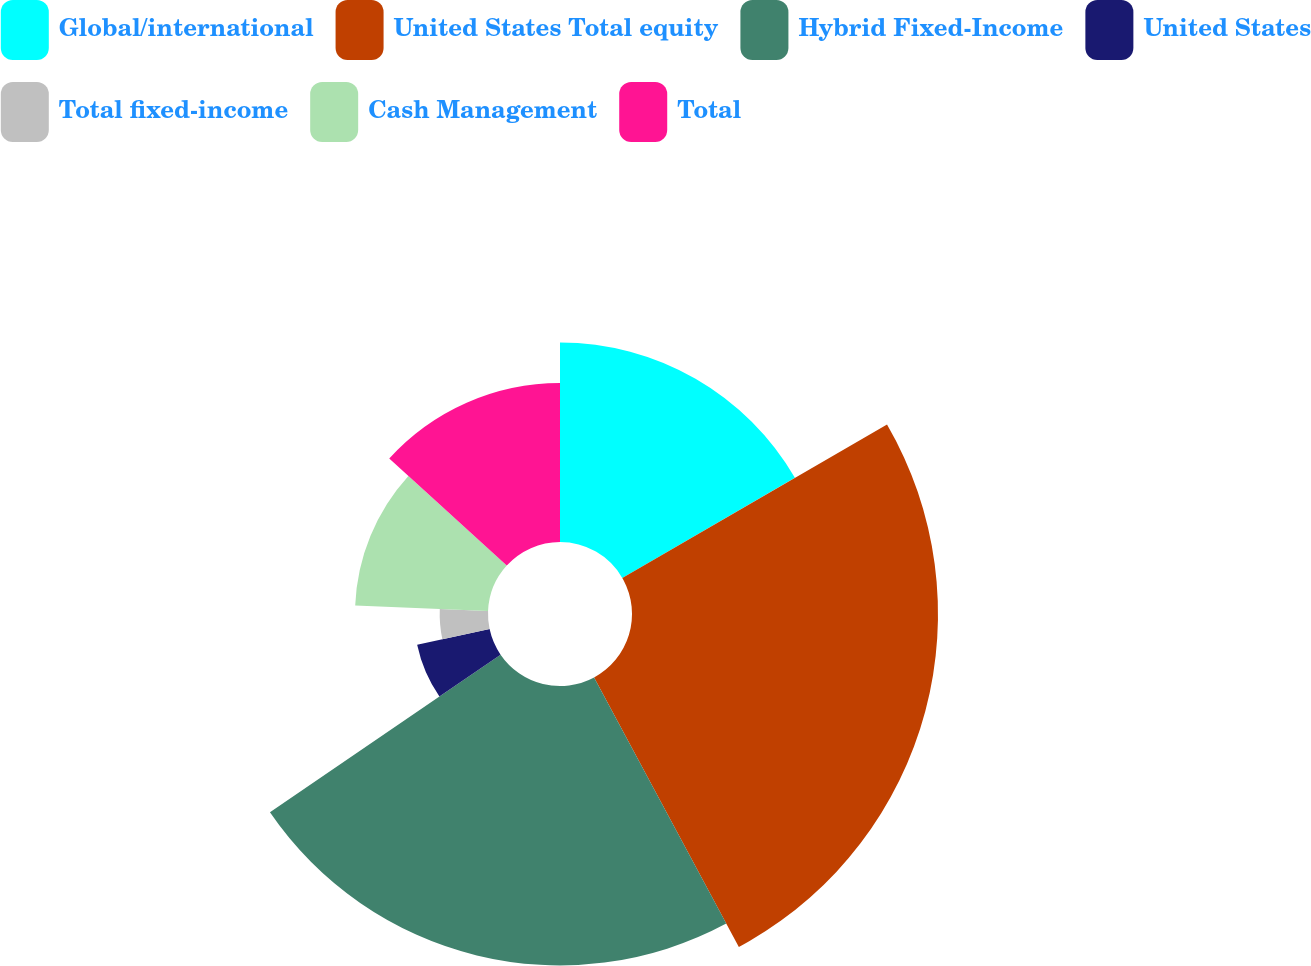Convert chart to OTSL. <chart><loc_0><loc_0><loc_500><loc_500><pie_chart><fcel>Global/international<fcel>United States Total equity<fcel>Hybrid Fixed-Income<fcel>United States<fcel>Total fixed-income<fcel>Cash Management<fcel>Total<nl><fcel>16.64%<fcel>25.52%<fcel>23.3%<fcel>6.18%<fcel>4.03%<fcel>11.09%<fcel>13.25%<nl></chart> 